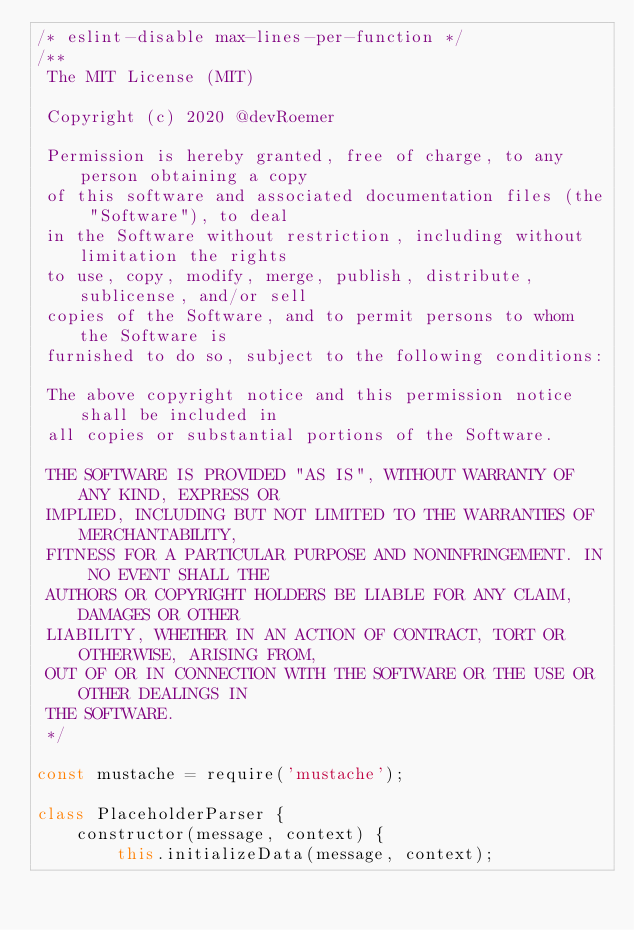Convert code to text. <code><loc_0><loc_0><loc_500><loc_500><_JavaScript_>/* eslint-disable max-lines-per-function */
/**
 The MIT License (MIT)

 Copyright (c) 2020 @devRoemer

 Permission is hereby granted, free of charge, to any person obtaining a copy
 of this software and associated documentation files (the "Software"), to deal
 in the Software without restriction, including without limitation the rights
 to use, copy, modify, merge, publish, distribute, sublicense, and/or sell
 copies of the Software, and to permit persons to whom the Software is
 furnished to do so, subject to the following conditions:

 The above copyright notice and this permission notice shall be included in
 all copies or substantial portions of the Software.

 THE SOFTWARE IS PROVIDED "AS IS", WITHOUT WARRANTY OF ANY KIND, EXPRESS OR
 IMPLIED, INCLUDING BUT NOT LIMITED TO THE WARRANTIES OF MERCHANTABILITY,
 FITNESS FOR A PARTICULAR PURPOSE AND NONINFRINGEMENT. IN NO EVENT SHALL THE
 AUTHORS OR COPYRIGHT HOLDERS BE LIABLE FOR ANY CLAIM, DAMAGES OR OTHER
 LIABILITY, WHETHER IN AN ACTION OF CONTRACT, TORT OR OTHERWISE, ARISING FROM,
 OUT OF OR IN CONNECTION WITH THE SOFTWARE OR THE USE OR OTHER DEALINGS IN
 THE SOFTWARE.
 */

const mustache = require('mustache');

class PlaceholderParser {
    constructor(message, context) {
        this.initializeData(message, context);</code> 